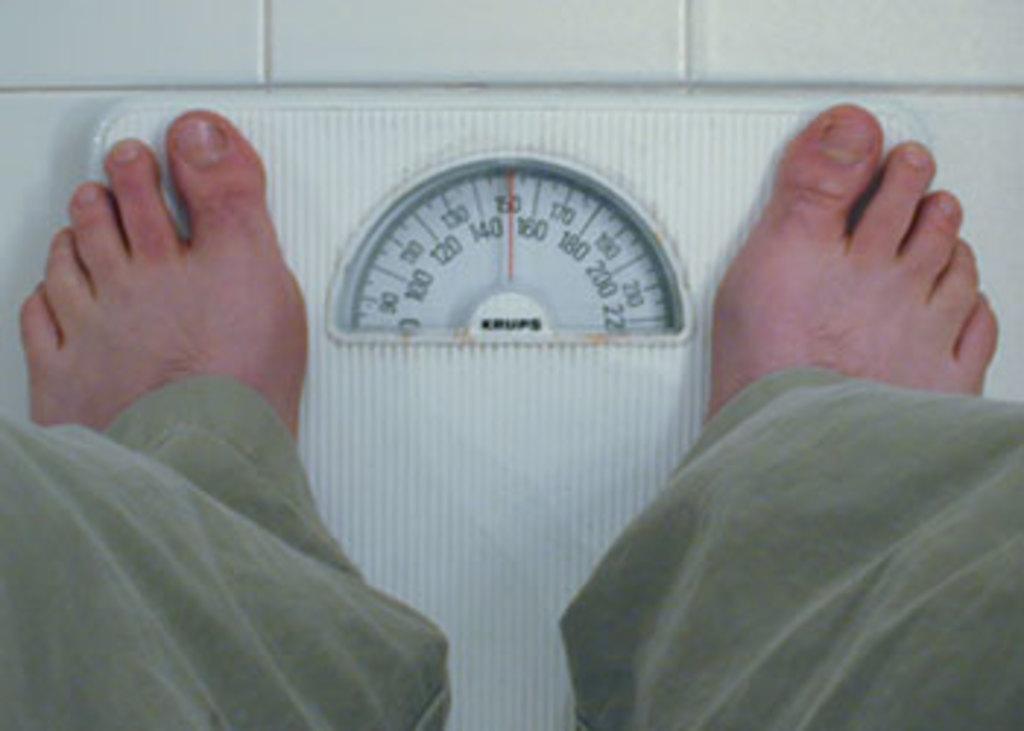In one or two sentences, can you explain what this image depicts? In the picture we can see a weight machine on the floor with meter and readings on it and a person feet on it. 